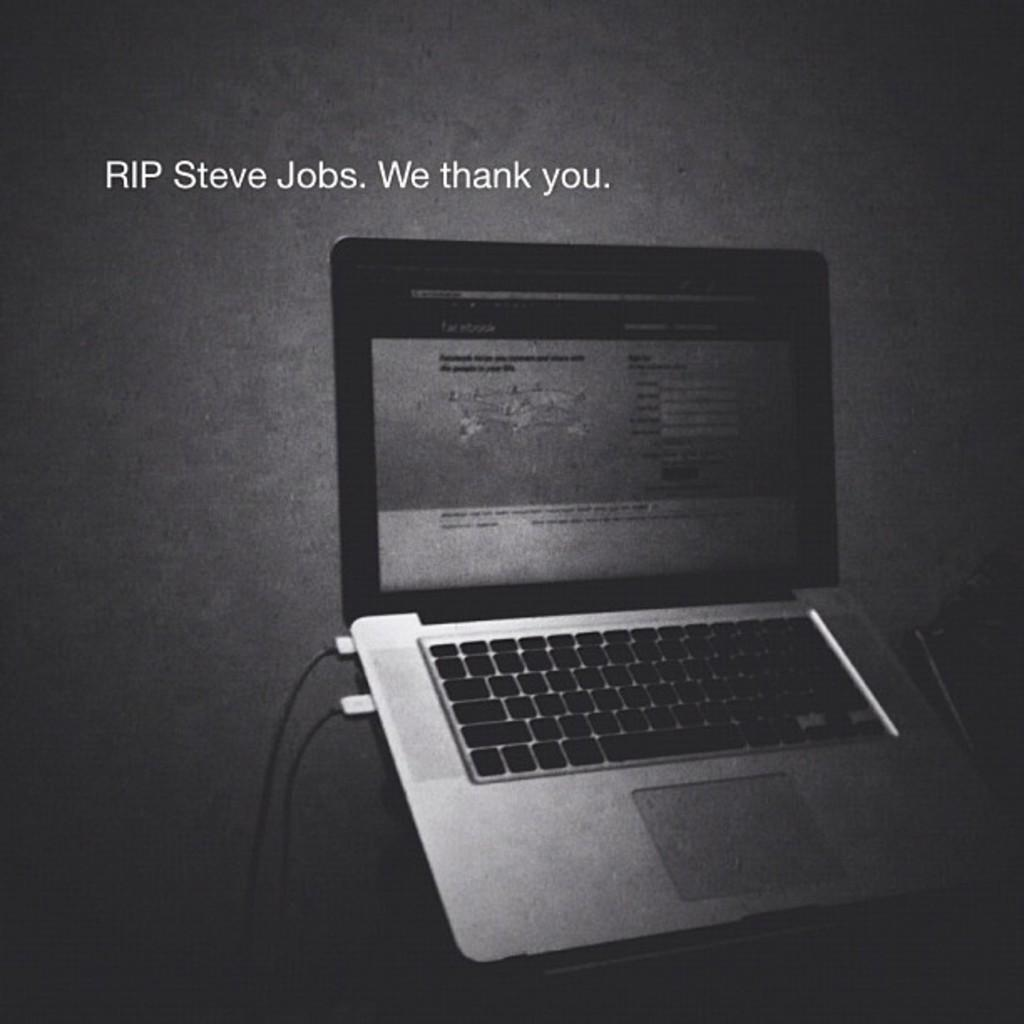What is the nature of the image? The image appears to be edited. What else can be seen in the image besides the edited appearance? There is text and a laptop visible in the image. What is the color of the background in the image? The background of the image is dark. How many slips can be seen in the image? There are no slips present in the image. What type of pocket is visible in the image? There is no pocket visible in the image. 